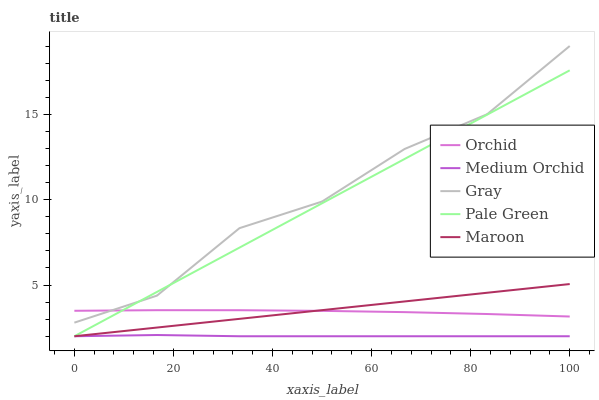Does Pale Green have the minimum area under the curve?
Answer yes or no. No. Does Pale Green have the maximum area under the curve?
Answer yes or no. No. Is Pale Green the smoothest?
Answer yes or no. No. Is Pale Green the roughest?
Answer yes or no. No. Does Orchid have the lowest value?
Answer yes or no. No. Does Pale Green have the highest value?
Answer yes or no. No. Is Maroon less than Gray?
Answer yes or no. Yes. Is Orchid greater than Medium Orchid?
Answer yes or no. Yes. Does Maroon intersect Gray?
Answer yes or no. No. 